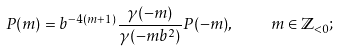<formula> <loc_0><loc_0><loc_500><loc_500>P ( m ) = b ^ { - 4 ( m + 1 ) } \frac { \gamma ( - m ) } { \gamma ( - m b ^ { 2 } ) } P ( - m ) , \quad m \in \mathbb { Z } _ { < 0 } ;</formula> 